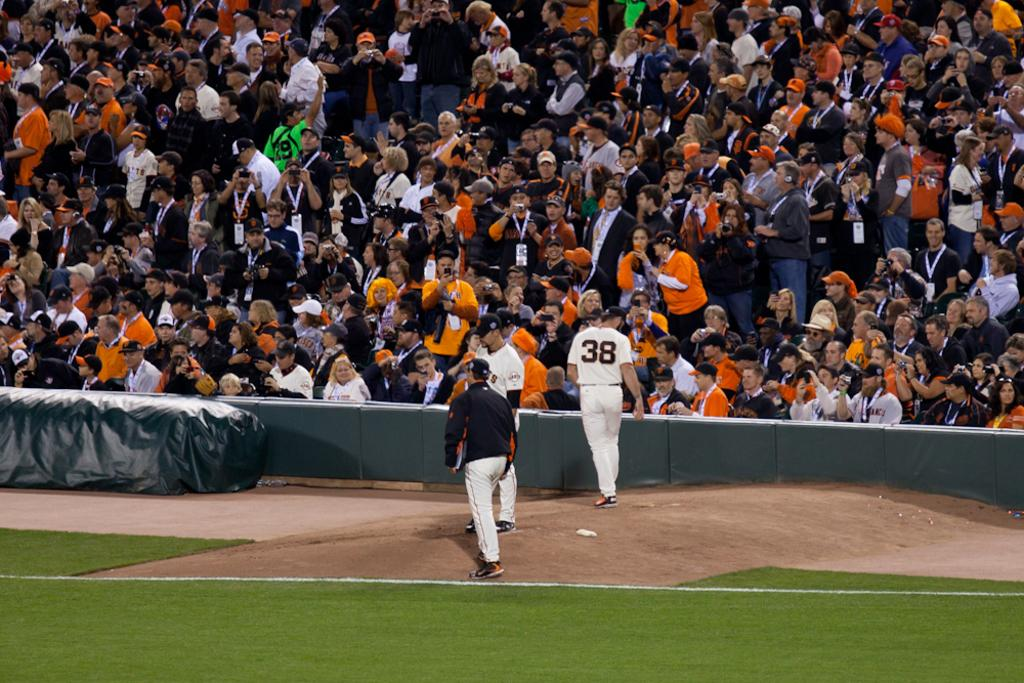Provide a one-sentence caption for the provided image. Three baseball players on the field with on wearing a number 38 jersey. 